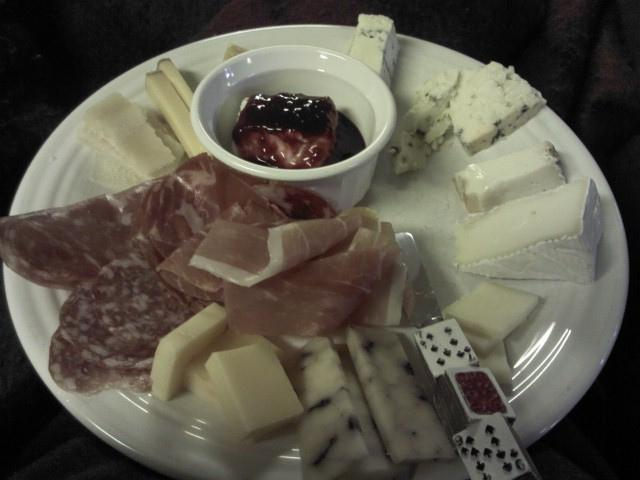What color is the back of the playing card printed cheese wedge? red 